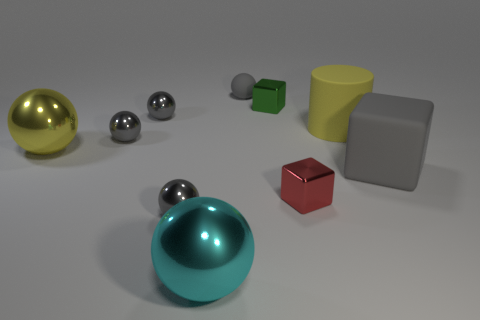What is the color of the rubber thing that is the same size as the yellow matte cylinder?
Keep it short and to the point. Gray. Are there an equal number of small green shiny things that are in front of the red metallic thing and big red shiny cubes?
Your answer should be compact. Yes. What shape is the thing that is both in front of the red shiny cube and on the left side of the cyan sphere?
Your answer should be compact. Sphere. Does the gray matte sphere have the same size as the cylinder?
Give a very brief answer. No. Is there another big cylinder that has the same material as the large cylinder?
Keep it short and to the point. No. There is a matte block that is the same color as the tiny rubber ball; what size is it?
Offer a very short reply. Large. What number of objects are both on the right side of the small green object and to the left of the big gray rubber cube?
Offer a very short reply. 2. What is the material of the small block that is in front of the green metal thing?
Ensure brevity in your answer.  Metal. How many balls have the same color as the matte cylinder?
Make the answer very short. 1. There is a cube that is the same material as the red thing; what is its size?
Give a very brief answer. Small. 